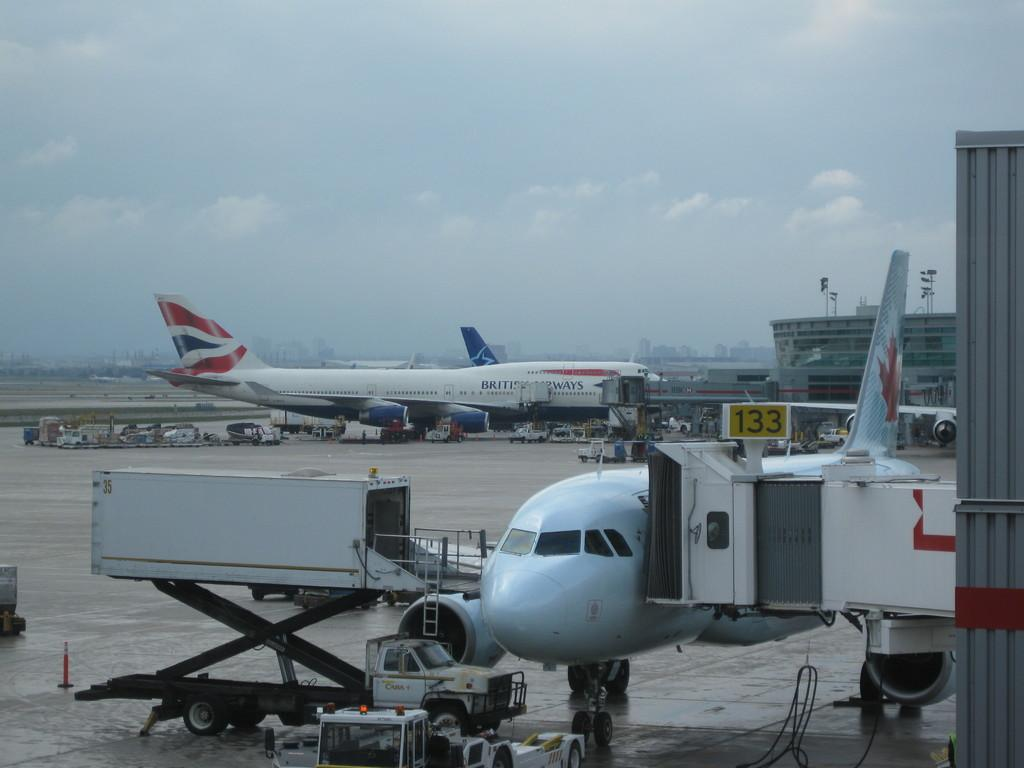<image>
Write a terse but informative summary of the picture. Two large British Airways jets are parked by terminal 133. 